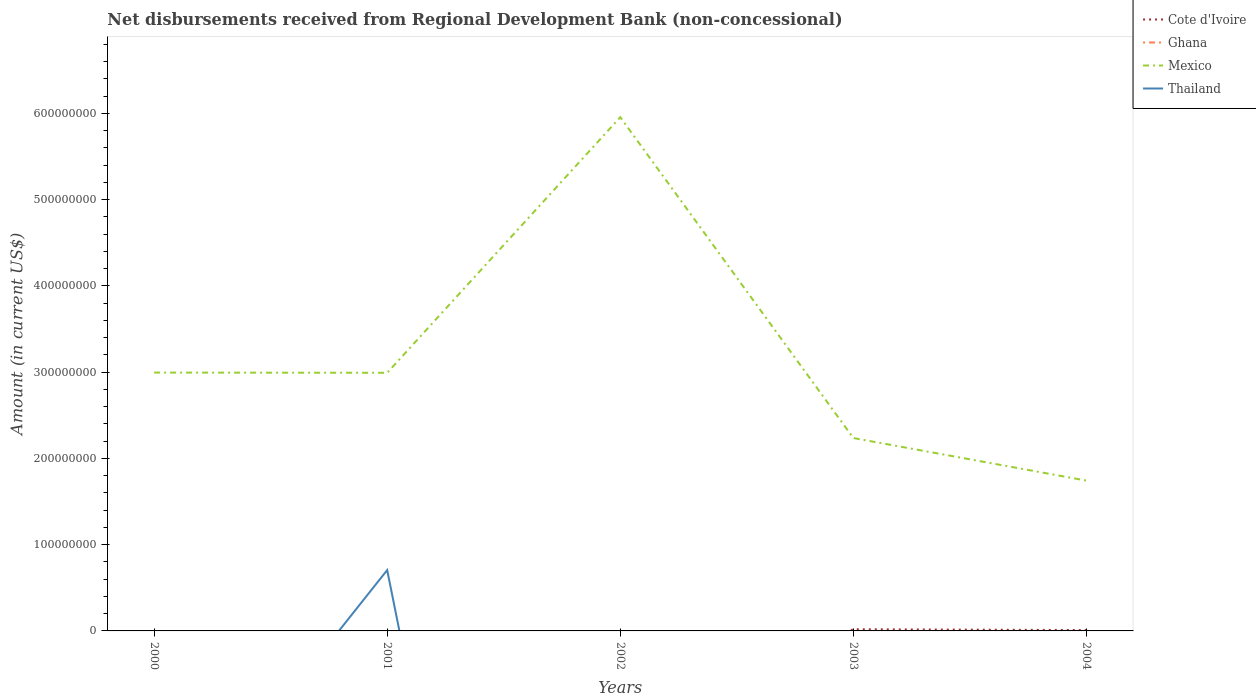What is the total amount of disbursements received from Regional Development Bank in Cote d'Ivoire in the graph?
Provide a short and direct response. 9.37e+05. What is the difference between the highest and the second highest amount of disbursements received from Regional Development Bank in Thailand?
Make the answer very short. 7.05e+07. What is the difference between the highest and the lowest amount of disbursements received from Regional Development Bank in Cote d'Ivoire?
Provide a succinct answer. 2. Is the amount of disbursements received from Regional Development Bank in Mexico strictly greater than the amount of disbursements received from Regional Development Bank in Thailand over the years?
Your answer should be compact. No. How many lines are there?
Make the answer very short. 3. Are the values on the major ticks of Y-axis written in scientific E-notation?
Offer a very short reply. No. Does the graph contain any zero values?
Make the answer very short. Yes. Does the graph contain grids?
Provide a succinct answer. No. Where does the legend appear in the graph?
Give a very brief answer. Top right. How are the legend labels stacked?
Provide a succinct answer. Vertical. What is the title of the graph?
Ensure brevity in your answer.  Net disbursements received from Regional Development Bank (non-concessional). Does "Burkina Faso" appear as one of the legend labels in the graph?
Keep it short and to the point. No. What is the label or title of the X-axis?
Make the answer very short. Years. What is the Amount (in current US$) of Cote d'Ivoire in 2000?
Make the answer very short. 0. What is the Amount (in current US$) of Ghana in 2000?
Your answer should be very brief. 0. What is the Amount (in current US$) in Mexico in 2000?
Your answer should be very brief. 2.99e+08. What is the Amount (in current US$) in Ghana in 2001?
Your answer should be very brief. 0. What is the Amount (in current US$) in Mexico in 2001?
Offer a terse response. 2.99e+08. What is the Amount (in current US$) of Thailand in 2001?
Provide a short and direct response. 7.05e+07. What is the Amount (in current US$) in Mexico in 2002?
Your response must be concise. 5.96e+08. What is the Amount (in current US$) in Thailand in 2002?
Your answer should be very brief. 0. What is the Amount (in current US$) of Cote d'Ivoire in 2003?
Make the answer very short. 1.93e+06. What is the Amount (in current US$) in Ghana in 2003?
Your answer should be very brief. 0. What is the Amount (in current US$) in Mexico in 2003?
Provide a short and direct response. 2.24e+08. What is the Amount (in current US$) of Thailand in 2003?
Ensure brevity in your answer.  0. What is the Amount (in current US$) of Cote d'Ivoire in 2004?
Your response must be concise. 9.91e+05. What is the Amount (in current US$) of Mexico in 2004?
Provide a succinct answer. 1.74e+08. What is the Amount (in current US$) of Thailand in 2004?
Offer a very short reply. 0. Across all years, what is the maximum Amount (in current US$) in Cote d'Ivoire?
Your answer should be compact. 1.93e+06. Across all years, what is the maximum Amount (in current US$) of Mexico?
Make the answer very short. 5.96e+08. Across all years, what is the maximum Amount (in current US$) of Thailand?
Give a very brief answer. 7.05e+07. Across all years, what is the minimum Amount (in current US$) in Cote d'Ivoire?
Give a very brief answer. 0. Across all years, what is the minimum Amount (in current US$) in Mexico?
Ensure brevity in your answer.  1.74e+08. Across all years, what is the minimum Amount (in current US$) in Thailand?
Provide a succinct answer. 0. What is the total Amount (in current US$) of Cote d'Ivoire in the graph?
Your answer should be very brief. 2.92e+06. What is the total Amount (in current US$) in Mexico in the graph?
Your answer should be compact. 1.59e+09. What is the total Amount (in current US$) in Thailand in the graph?
Make the answer very short. 7.05e+07. What is the difference between the Amount (in current US$) of Mexico in 2000 and that in 2001?
Provide a short and direct response. 2.70e+05. What is the difference between the Amount (in current US$) of Mexico in 2000 and that in 2002?
Your answer should be compact. -2.96e+08. What is the difference between the Amount (in current US$) in Mexico in 2000 and that in 2003?
Your response must be concise. 7.59e+07. What is the difference between the Amount (in current US$) in Mexico in 2000 and that in 2004?
Make the answer very short. 1.25e+08. What is the difference between the Amount (in current US$) in Mexico in 2001 and that in 2002?
Keep it short and to the point. -2.96e+08. What is the difference between the Amount (in current US$) in Mexico in 2001 and that in 2003?
Your answer should be very brief. 7.56e+07. What is the difference between the Amount (in current US$) of Mexico in 2001 and that in 2004?
Keep it short and to the point. 1.25e+08. What is the difference between the Amount (in current US$) of Mexico in 2002 and that in 2003?
Offer a terse response. 3.72e+08. What is the difference between the Amount (in current US$) of Mexico in 2002 and that in 2004?
Provide a short and direct response. 4.21e+08. What is the difference between the Amount (in current US$) of Cote d'Ivoire in 2003 and that in 2004?
Give a very brief answer. 9.37e+05. What is the difference between the Amount (in current US$) in Mexico in 2003 and that in 2004?
Offer a very short reply. 4.93e+07. What is the difference between the Amount (in current US$) of Mexico in 2000 and the Amount (in current US$) of Thailand in 2001?
Give a very brief answer. 2.29e+08. What is the difference between the Amount (in current US$) of Cote d'Ivoire in 2003 and the Amount (in current US$) of Mexico in 2004?
Your answer should be compact. -1.72e+08. What is the average Amount (in current US$) of Cote d'Ivoire per year?
Provide a succinct answer. 5.84e+05. What is the average Amount (in current US$) in Mexico per year?
Offer a very short reply. 3.18e+08. What is the average Amount (in current US$) in Thailand per year?
Your response must be concise. 1.41e+07. In the year 2001, what is the difference between the Amount (in current US$) of Mexico and Amount (in current US$) of Thailand?
Offer a very short reply. 2.29e+08. In the year 2003, what is the difference between the Amount (in current US$) in Cote d'Ivoire and Amount (in current US$) in Mexico?
Keep it short and to the point. -2.22e+08. In the year 2004, what is the difference between the Amount (in current US$) of Cote d'Ivoire and Amount (in current US$) of Mexico?
Offer a very short reply. -1.73e+08. What is the ratio of the Amount (in current US$) of Mexico in 2000 to that in 2002?
Your answer should be very brief. 0.5. What is the ratio of the Amount (in current US$) of Mexico in 2000 to that in 2003?
Keep it short and to the point. 1.34. What is the ratio of the Amount (in current US$) of Mexico in 2000 to that in 2004?
Your answer should be compact. 1.72. What is the ratio of the Amount (in current US$) in Mexico in 2001 to that in 2002?
Your answer should be compact. 0.5. What is the ratio of the Amount (in current US$) of Mexico in 2001 to that in 2003?
Your response must be concise. 1.34. What is the ratio of the Amount (in current US$) in Mexico in 2001 to that in 2004?
Offer a very short reply. 1.72. What is the ratio of the Amount (in current US$) in Mexico in 2002 to that in 2003?
Your answer should be very brief. 2.66. What is the ratio of the Amount (in current US$) of Mexico in 2002 to that in 2004?
Your answer should be compact. 3.42. What is the ratio of the Amount (in current US$) in Cote d'Ivoire in 2003 to that in 2004?
Offer a very short reply. 1.95. What is the ratio of the Amount (in current US$) of Mexico in 2003 to that in 2004?
Offer a very short reply. 1.28. What is the difference between the highest and the second highest Amount (in current US$) of Mexico?
Provide a succinct answer. 2.96e+08. What is the difference between the highest and the lowest Amount (in current US$) in Cote d'Ivoire?
Offer a very short reply. 1.93e+06. What is the difference between the highest and the lowest Amount (in current US$) of Mexico?
Offer a terse response. 4.21e+08. What is the difference between the highest and the lowest Amount (in current US$) in Thailand?
Provide a succinct answer. 7.05e+07. 